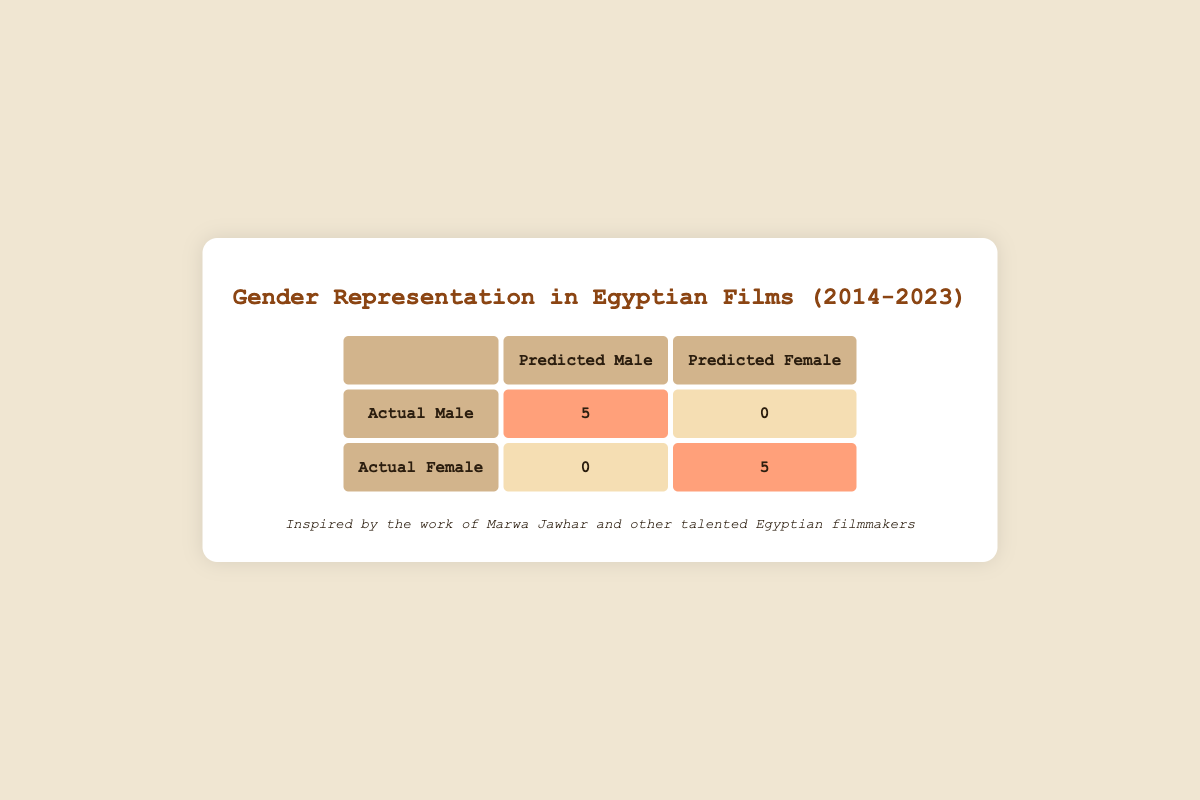What is the total number of films with male lead roles? The table shows that there are 5 actual male leads, as indicated in the row for "Actual Male" under the "Predicted Male" column. So the total is 5.
Answer: 5 What is the total number of films with female lead roles? The table indicates that there are 5 actual female leads, as shown in the row for "Actual Female" under the "Predicted Female" column. Thus, the total is 5.
Answer: 5 How many films had male leads predicted as female? By looking at the table, the value in the intersection of "Actual Male" and "Predicted Female" is 0, indicating no films had male leads that were predicted as female.
Answer: 0 How many films had female leads predicted as male? The table shows that in the intersection of "Actual Female" and "Predicted Male," there is also a value of 0, meaning there were no films with female leads predicted as male.
Answer: 0 What is the ratio of films with male lead roles to films with female lead roles? There are 5 films with male leads and 5 with female leads. To find the ratio, we divide the number of male roles by the number of female roles: 5/5 which simplifies to 1:1.
Answer: 1:1 Is it true that all films feature either male or female leads without any overlapping categories? According to the table, there are separate counts for male and female leads, with no overlap indicated (0 in both off-diagonal cells), confirming that this statement is true.
Answer: Yes Which gender had a higher representation in lead roles? Since both male and female lead roles are equal at a total of 5 each, neither gender had a higher representation in lead roles.
Answer: Neither If a new film with a female lead is added, what would be the new total for female leads? Currently, there are 5 female leads. Adding one more would make it 5 + 1 = 6.
Answer: 6 What percentage of the total films were female leads? There are 10 total films (5 male + 5 female). The percentage of female leads is (5/10) * 100 = 50%.
Answer: 50% 